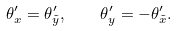<formula> <loc_0><loc_0><loc_500><loc_500>\theta ^ { \prime } _ { x } = \theta ^ { \prime } _ { \tilde { y } } , \quad \theta ^ { \prime } _ { y } = - \theta ^ { \prime } _ { \tilde { x } } .</formula> 